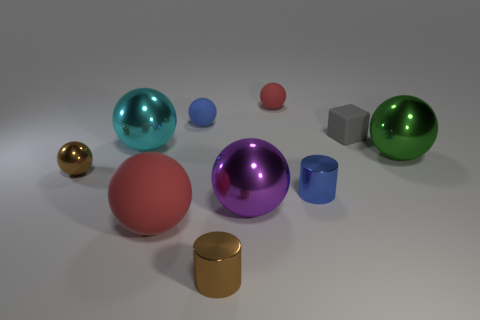There is a small shiny object that is both on the right side of the blue ball and behind the brown cylinder; what shape is it?
Ensure brevity in your answer.  Cylinder. Is there a large purple metallic object?
Provide a succinct answer. Yes. There is a tiny red object that is the same shape as the blue matte object; what material is it?
Offer a terse response. Rubber. There is a small brown thing in front of the red rubber thing that is in front of the purple shiny sphere to the left of the small red sphere; what shape is it?
Offer a very short reply. Cylinder. There is a object that is the same color as the big matte ball; what is it made of?
Keep it short and to the point. Rubber. How many big blue objects have the same shape as the big green object?
Keep it short and to the point. 0. There is a rubber object that is in front of the small matte block; does it have the same color as the big metallic sphere on the left side of the big red matte sphere?
Make the answer very short. No. There is a purple sphere that is the same size as the cyan metallic object; what is its material?
Make the answer very short. Metal. Are there any yellow shiny blocks that have the same size as the green ball?
Make the answer very short. No. Are there fewer blue cylinders to the left of the tiny brown metallic cylinder than cyan things?
Keep it short and to the point. Yes. 